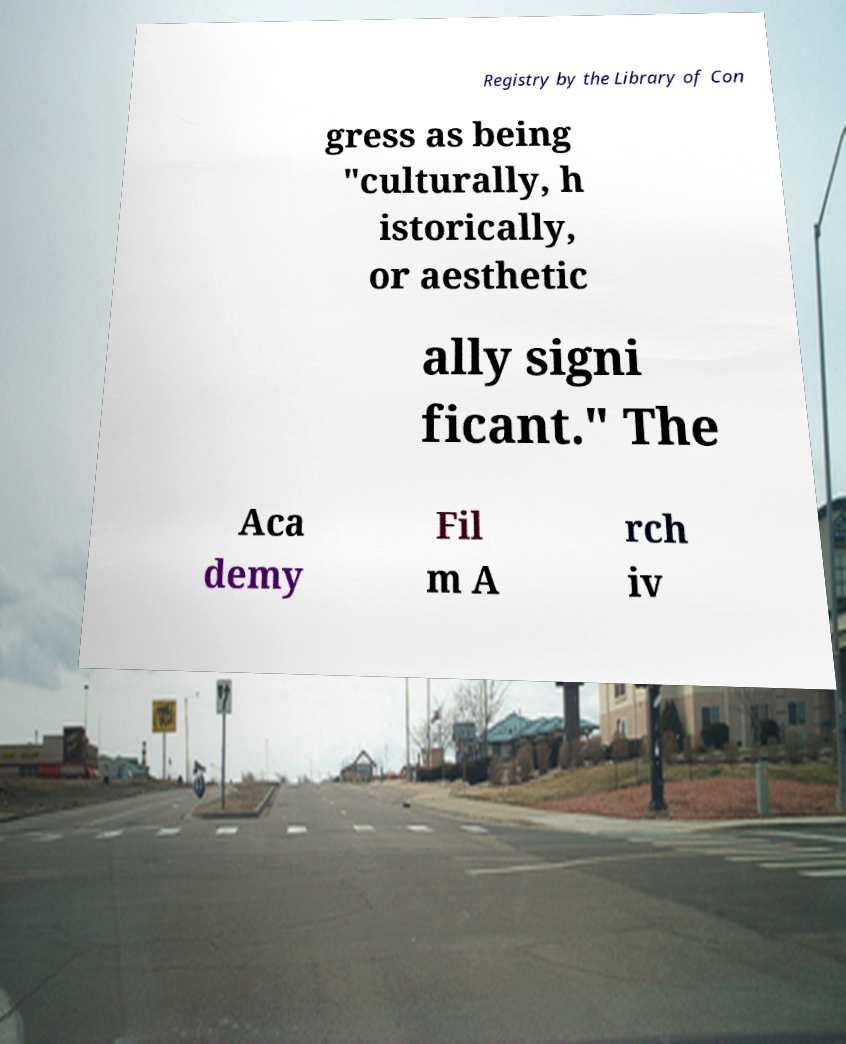Can you accurately transcribe the text from the provided image for me? Registry by the Library of Con gress as being "culturally, h istorically, or aesthetic ally signi ficant." The Aca demy Fil m A rch iv 